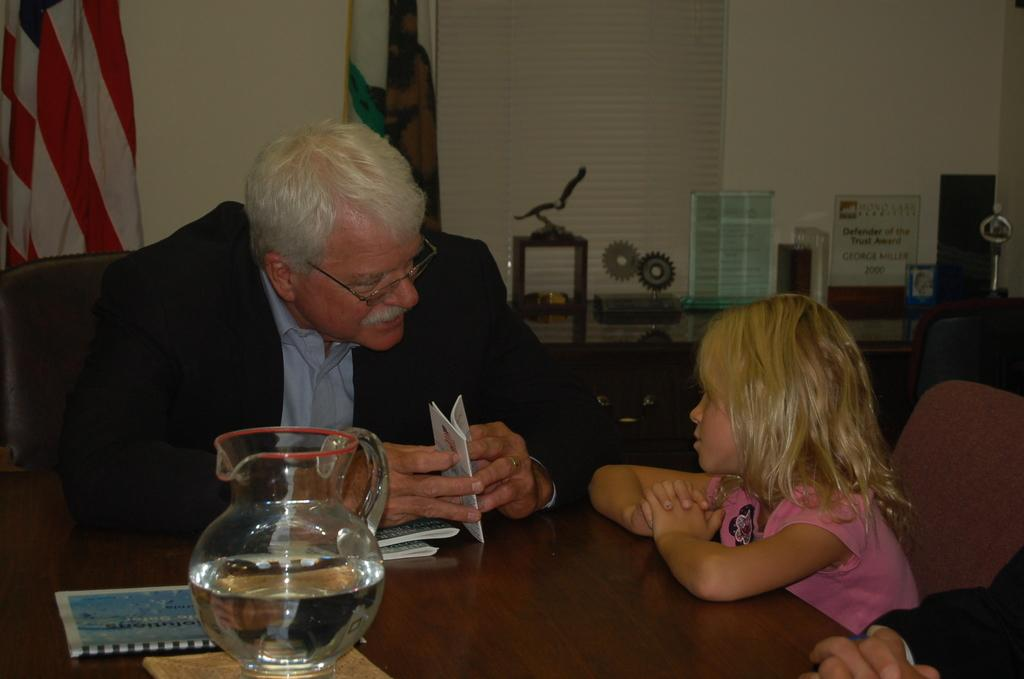Who is present in the image? There is a man and a baby girl in the image. What is the man doing in the image? The man is sitting on a chair and speaking with a baby girl. What is the baby girl doing in the image? The baby girl is sitting on a chair. What is the man wearing in the image? The man is wearing a coat. What type of lumber is the man using to support the yoke in the image? There is no lumber or yoke present in the image; it features a man and a baby girl sitting on chairs and talking. 